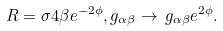Convert formula to latex. <formula><loc_0><loc_0><loc_500><loc_500>R = \sigma 4 \beta e ^ { - 2 \phi } , g _ { \alpha \beta } \rightarrow \, g _ { \alpha \beta } e ^ { 2 \phi } .</formula> 